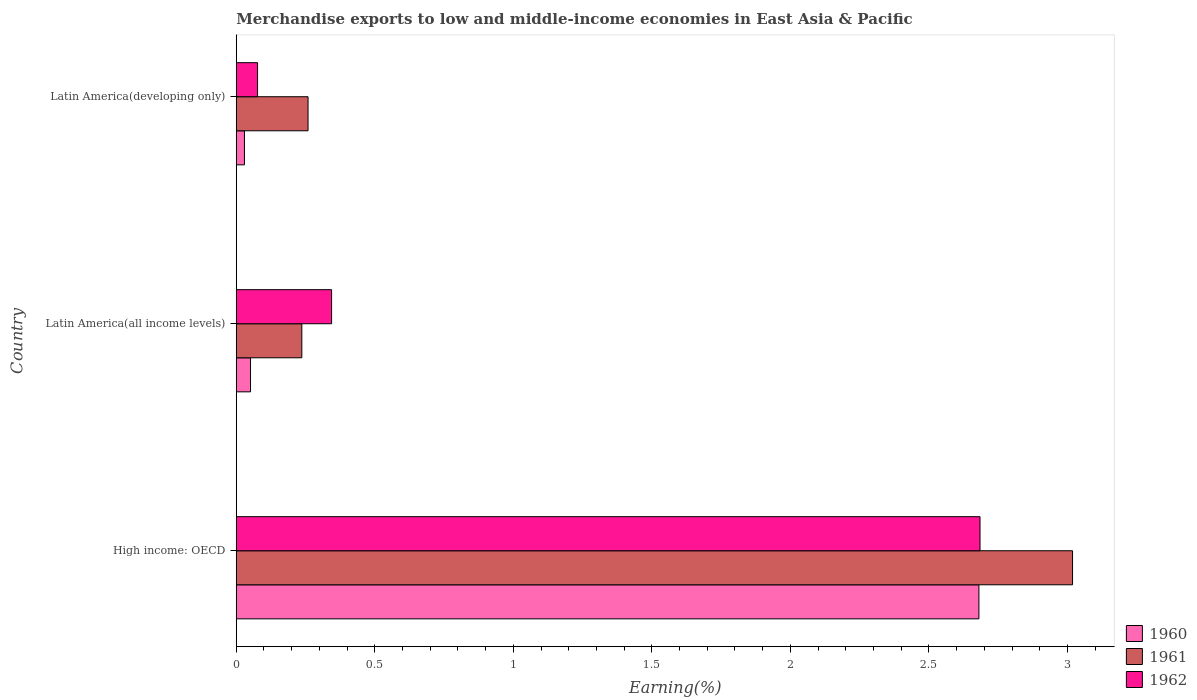How many bars are there on the 2nd tick from the top?
Your answer should be compact. 3. What is the label of the 1st group of bars from the top?
Make the answer very short. Latin America(developing only). In how many cases, is the number of bars for a given country not equal to the number of legend labels?
Provide a succinct answer. 0. What is the percentage of amount earned from merchandise exports in 1961 in High income: OECD?
Offer a terse response. 3.02. Across all countries, what is the maximum percentage of amount earned from merchandise exports in 1960?
Make the answer very short. 2.68. Across all countries, what is the minimum percentage of amount earned from merchandise exports in 1962?
Ensure brevity in your answer.  0.08. In which country was the percentage of amount earned from merchandise exports in 1960 maximum?
Keep it short and to the point. High income: OECD. In which country was the percentage of amount earned from merchandise exports in 1961 minimum?
Your response must be concise. Latin America(all income levels). What is the total percentage of amount earned from merchandise exports in 1962 in the graph?
Provide a succinct answer. 3.11. What is the difference between the percentage of amount earned from merchandise exports in 1960 in High income: OECD and that in Latin America(developing only)?
Provide a succinct answer. 2.65. What is the difference between the percentage of amount earned from merchandise exports in 1962 in High income: OECD and the percentage of amount earned from merchandise exports in 1961 in Latin America(developing only)?
Keep it short and to the point. 2.43. What is the average percentage of amount earned from merchandise exports in 1962 per country?
Your answer should be very brief. 1.04. What is the difference between the percentage of amount earned from merchandise exports in 1961 and percentage of amount earned from merchandise exports in 1960 in Latin America(developing only)?
Make the answer very short. 0.23. In how many countries, is the percentage of amount earned from merchandise exports in 1961 greater than 0.1 %?
Your response must be concise. 3. What is the ratio of the percentage of amount earned from merchandise exports in 1960 in High income: OECD to that in Latin America(all income levels)?
Offer a terse response. 52.09. Is the difference between the percentage of amount earned from merchandise exports in 1961 in High income: OECD and Latin America(all income levels) greater than the difference between the percentage of amount earned from merchandise exports in 1960 in High income: OECD and Latin America(all income levels)?
Make the answer very short. Yes. What is the difference between the highest and the second highest percentage of amount earned from merchandise exports in 1962?
Your answer should be compact. 2.34. What is the difference between the highest and the lowest percentage of amount earned from merchandise exports in 1962?
Make the answer very short. 2.61. What does the 3rd bar from the top in Latin America(developing only) represents?
Give a very brief answer. 1960. What does the 2nd bar from the bottom in Latin America(developing only) represents?
Make the answer very short. 1961. Are all the bars in the graph horizontal?
Keep it short and to the point. Yes. How many countries are there in the graph?
Provide a short and direct response. 3. Are the values on the major ticks of X-axis written in scientific E-notation?
Ensure brevity in your answer.  No. Does the graph contain any zero values?
Provide a short and direct response. No. How many legend labels are there?
Your answer should be very brief. 3. What is the title of the graph?
Make the answer very short. Merchandise exports to low and middle-income economies in East Asia & Pacific. What is the label or title of the X-axis?
Your answer should be compact. Earning(%). What is the label or title of the Y-axis?
Provide a short and direct response. Country. What is the Earning(%) in 1960 in High income: OECD?
Give a very brief answer. 2.68. What is the Earning(%) in 1961 in High income: OECD?
Your answer should be very brief. 3.02. What is the Earning(%) of 1962 in High income: OECD?
Give a very brief answer. 2.68. What is the Earning(%) of 1960 in Latin America(all income levels)?
Offer a terse response. 0.05. What is the Earning(%) of 1961 in Latin America(all income levels)?
Give a very brief answer. 0.24. What is the Earning(%) of 1962 in Latin America(all income levels)?
Ensure brevity in your answer.  0.34. What is the Earning(%) of 1960 in Latin America(developing only)?
Offer a terse response. 0.03. What is the Earning(%) in 1961 in Latin America(developing only)?
Offer a terse response. 0.26. What is the Earning(%) of 1962 in Latin America(developing only)?
Your answer should be compact. 0.08. Across all countries, what is the maximum Earning(%) of 1960?
Your answer should be very brief. 2.68. Across all countries, what is the maximum Earning(%) of 1961?
Ensure brevity in your answer.  3.02. Across all countries, what is the maximum Earning(%) in 1962?
Keep it short and to the point. 2.68. Across all countries, what is the minimum Earning(%) of 1960?
Give a very brief answer. 0.03. Across all countries, what is the minimum Earning(%) of 1961?
Ensure brevity in your answer.  0.24. Across all countries, what is the minimum Earning(%) in 1962?
Your response must be concise. 0.08. What is the total Earning(%) of 1960 in the graph?
Your answer should be very brief. 2.76. What is the total Earning(%) in 1961 in the graph?
Your answer should be compact. 3.51. What is the total Earning(%) of 1962 in the graph?
Provide a succinct answer. 3.11. What is the difference between the Earning(%) in 1960 in High income: OECD and that in Latin America(all income levels)?
Make the answer very short. 2.63. What is the difference between the Earning(%) in 1961 in High income: OECD and that in Latin America(all income levels)?
Offer a very short reply. 2.78. What is the difference between the Earning(%) in 1962 in High income: OECD and that in Latin America(all income levels)?
Your answer should be compact. 2.34. What is the difference between the Earning(%) in 1960 in High income: OECD and that in Latin America(developing only)?
Offer a very short reply. 2.65. What is the difference between the Earning(%) of 1961 in High income: OECD and that in Latin America(developing only)?
Offer a terse response. 2.76. What is the difference between the Earning(%) in 1962 in High income: OECD and that in Latin America(developing only)?
Your response must be concise. 2.61. What is the difference between the Earning(%) in 1960 in Latin America(all income levels) and that in Latin America(developing only)?
Make the answer very short. 0.02. What is the difference between the Earning(%) in 1961 in Latin America(all income levels) and that in Latin America(developing only)?
Provide a succinct answer. -0.02. What is the difference between the Earning(%) in 1962 in Latin America(all income levels) and that in Latin America(developing only)?
Offer a terse response. 0.27. What is the difference between the Earning(%) in 1960 in High income: OECD and the Earning(%) in 1961 in Latin America(all income levels)?
Offer a very short reply. 2.44. What is the difference between the Earning(%) in 1960 in High income: OECD and the Earning(%) in 1962 in Latin America(all income levels)?
Make the answer very short. 2.34. What is the difference between the Earning(%) in 1961 in High income: OECD and the Earning(%) in 1962 in Latin America(all income levels)?
Give a very brief answer. 2.67. What is the difference between the Earning(%) in 1960 in High income: OECD and the Earning(%) in 1961 in Latin America(developing only)?
Offer a very short reply. 2.42. What is the difference between the Earning(%) of 1960 in High income: OECD and the Earning(%) of 1962 in Latin America(developing only)?
Offer a very short reply. 2.6. What is the difference between the Earning(%) in 1961 in High income: OECD and the Earning(%) in 1962 in Latin America(developing only)?
Keep it short and to the point. 2.94. What is the difference between the Earning(%) of 1960 in Latin America(all income levels) and the Earning(%) of 1961 in Latin America(developing only)?
Ensure brevity in your answer.  -0.21. What is the difference between the Earning(%) of 1960 in Latin America(all income levels) and the Earning(%) of 1962 in Latin America(developing only)?
Give a very brief answer. -0.03. What is the difference between the Earning(%) of 1961 in Latin America(all income levels) and the Earning(%) of 1962 in Latin America(developing only)?
Ensure brevity in your answer.  0.16. What is the average Earning(%) of 1960 per country?
Give a very brief answer. 0.92. What is the average Earning(%) of 1961 per country?
Your answer should be very brief. 1.17. What is the average Earning(%) in 1962 per country?
Keep it short and to the point. 1.04. What is the difference between the Earning(%) of 1960 and Earning(%) of 1961 in High income: OECD?
Make the answer very short. -0.34. What is the difference between the Earning(%) of 1960 and Earning(%) of 1962 in High income: OECD?
Offer a very short reply. -0. What is the difference between the Earning(%) in 1961 and Earning(%) in 1962 in High income: OECD?
Offer a very short reply. 0.33. What is the difference between the Earning(%) in 1960 and Earning(%) in 1961 in Latin America(all income levels)?
Your response must be concise. -0.19. What is the difference between the Earning(%) of 1960 and Earning(%) of 1962 in Latin America(all income levels)?
Offer a terse response. -0.29. What is the difference between the Earning(%) of 1961 and Earning(%) of 1962 in Latin America(all income levels)?
Provide a short and direct response. -0.11. What is the difference between the Earning(%) in 1960 and Earning(%) in 1961 in Latin America(developing only)?
Give a very brief answer. -0.23. What is the difference between the Earning(%) of 1960 and Earning(%) of 1962 in Latin America(developing only)?
Your answer should be very brief. -0.05. What is the difference between the Earning(%) in 1961 and Earning(%) in 1962 in Latin America(developing only)?
Offer a terse response. 0.18. What is the ratio of the Earning(%) of 1960 in High income: OECD to that in Latin America(all income levels)?
Your response must be concise. 52.09. What is the ratio of the Earning(%) in 1961 in High income: OECD to that in Latin America(all income levels)?
Offer a terse response. 12.75. What is the ratio of the Earning(%) of 1962 in High income: OECD to that in Latin America(all income levels)?
Provide a succinct answer. 7.8. What is the ratio of the Earning(%) of 1960 in High income: OECD to that in Latin America(developing only)?
Your answer should be compact. 90.55. What is the ratio of the Earning(%) of 1961 in High income: OECD to that in Latin America(developing only)?
Keep it short and to the point. 11.65. What is the ratio of the Earning(%) of 1962 in High income: OECD to that in Latin America(developing only)?
Make the answer very short. 34.9. What is the ratio of the Earning(%) of 1960 in Latin America(all income levels) to that in Latin America(developing only)?
Your answer should be very brief. 1.74. What is the ratio of the Earning(%) of 1961 in Latin America(all income levels) to that in Latin America(developing only)?
Provide a short and direct response. 0.91. What is the ratio of the Earning(%) of 1962 in Latin America(all income levels) to that in Latin America(developing only)?
Give a very brief answer. 4.47. What is the difference between the highest and the second highest Earning(%) of 1960?
Make the answer very short. 2.63. What is the difference between the highest and the second highest Earning(%) of 1961?
Give a very brief answer. 2.76. What is the difference between the highest and the second highest Earning(%) in 1962?
Your response must be concise. 2.34. What is the difference between the highest and the lowest Earning(%) in 1960?
Provide a succinct answer. 2.65. What is the difference between the highest and the lowest Earning(%) in 1961?
Provide a succinct answer. 2.78. What is the difference between the highest and the lowest Earning(%) of 1962?
Your answer should be very brief. 2.61. 